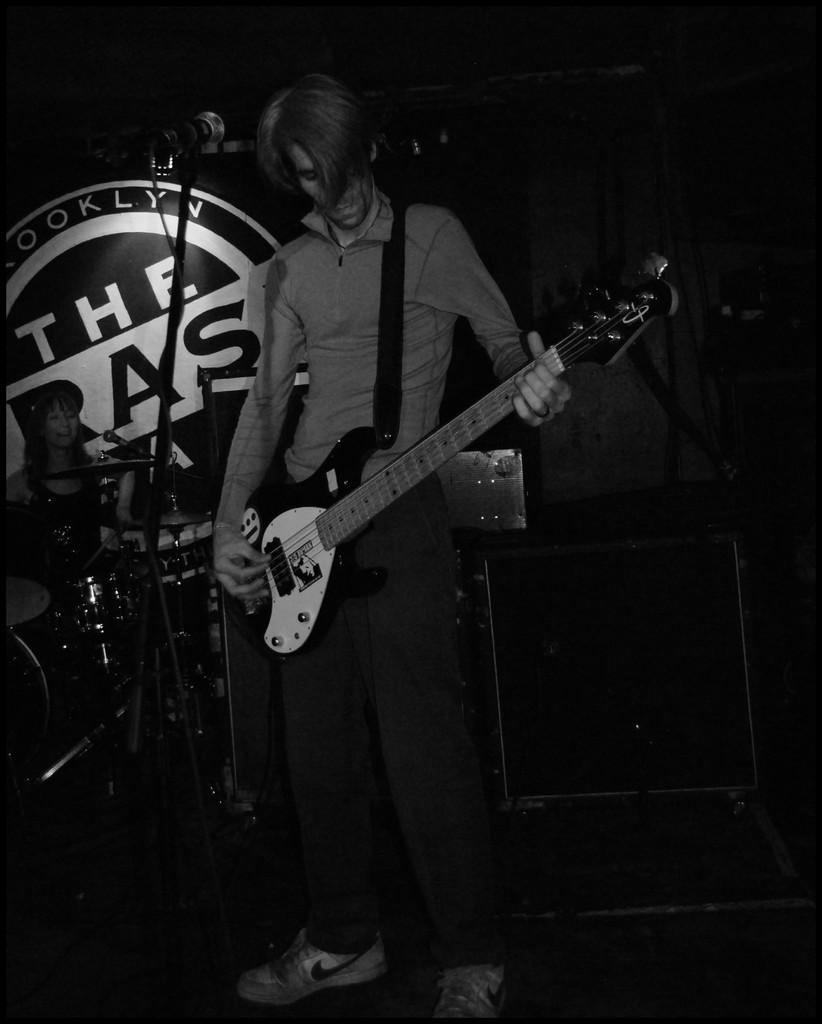What is the man in the image doing? The man in the image is playing a guitar. What object is in front of the man? There is a microphone in front of the man. Can you describe the woman in the image? The woman is seated in the image. What type of wound can be seen on the guitar in the image? There is no wound visible on the guitar in the image, as it is a musical instrument and not a living being. 